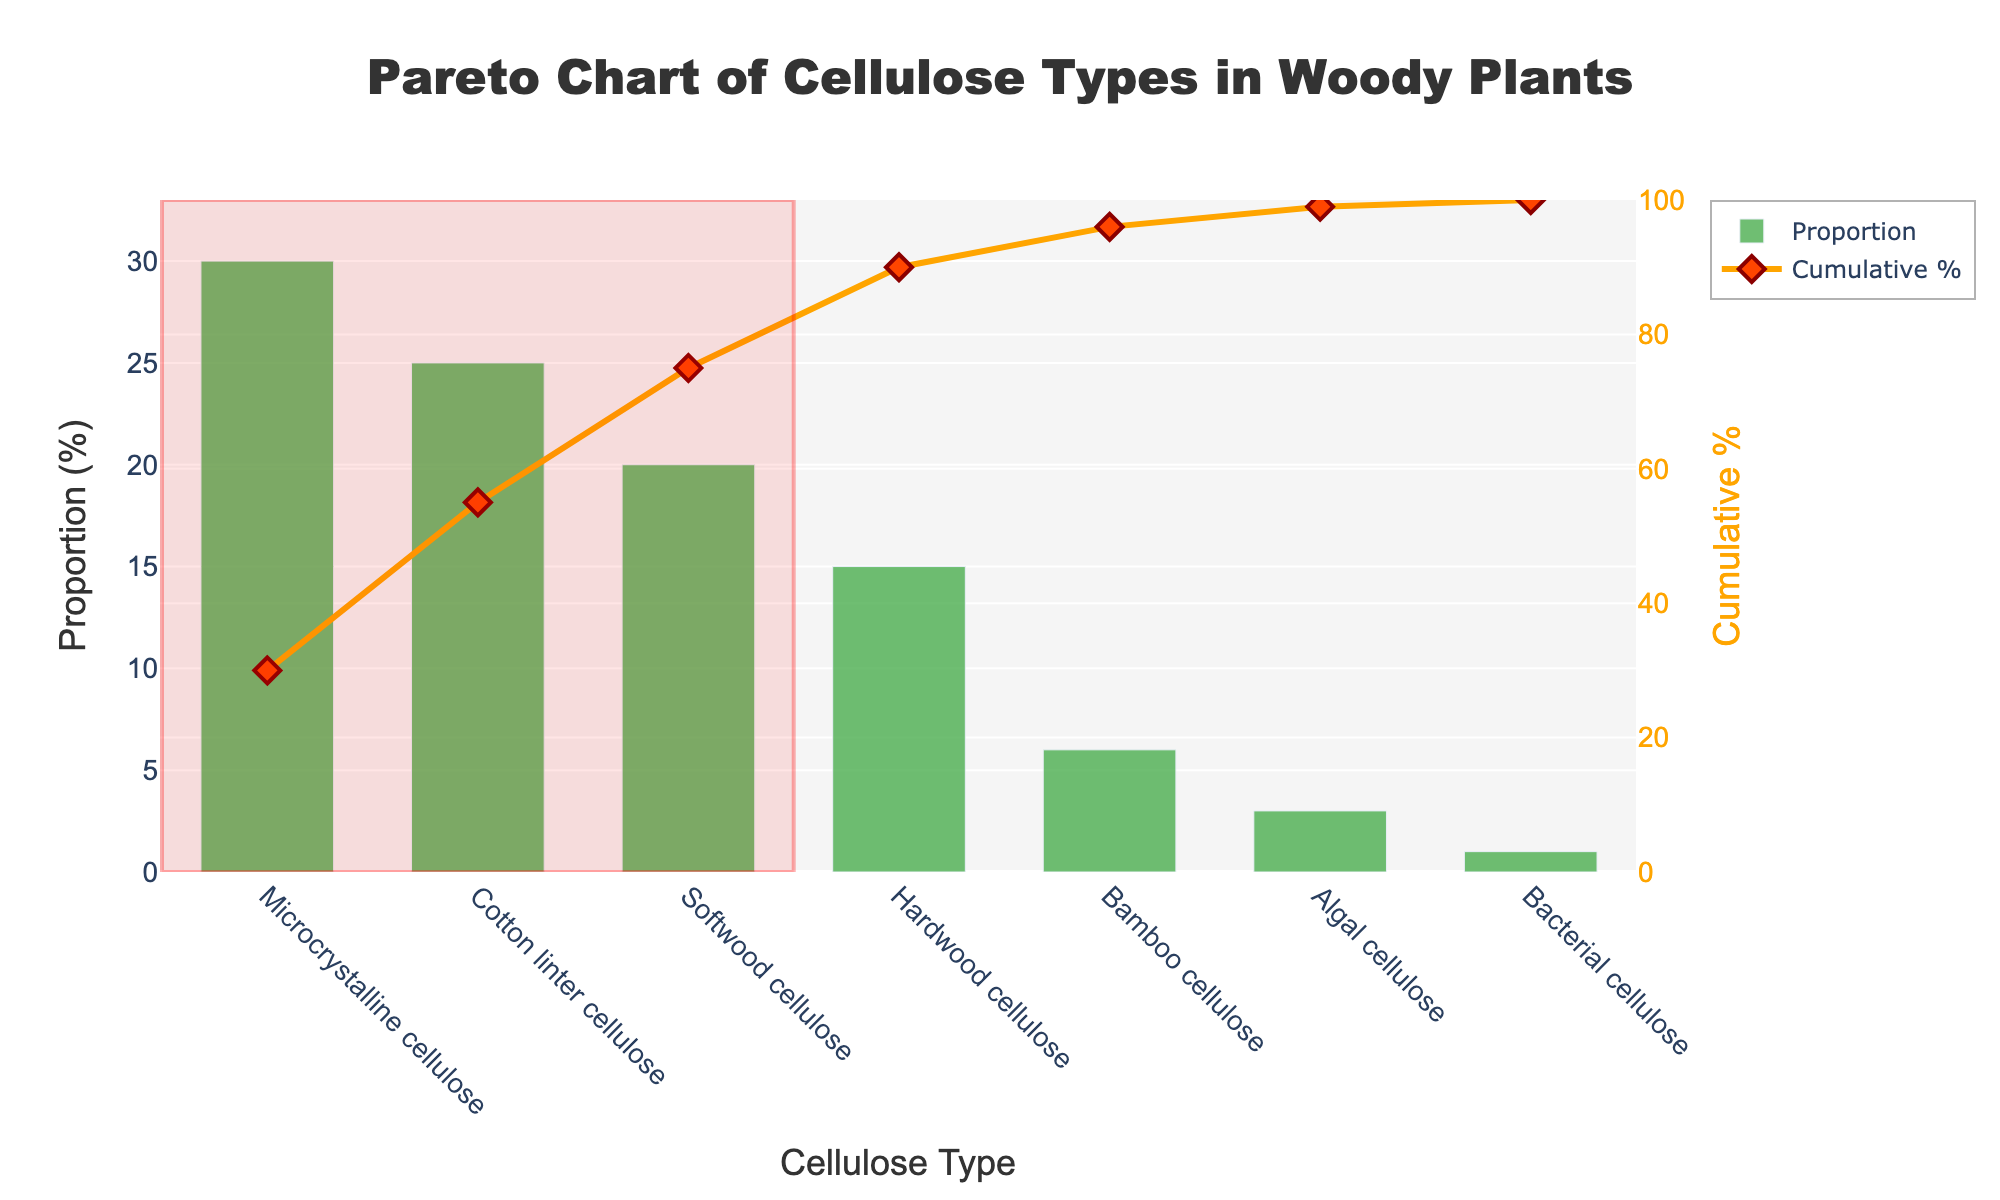What's the title of the figure? The title is prominently displayed at the top of the figure.
Answer: Pareto Chart of Cellulose Types in Woody Plants What do the x-axis and the left y-axis represent? The x-axis represents different types of cellulose, and the left y-axis represents the proportion (%) of each cellulose type.
Answer: Cellulose Type and Proportion (%) Which cellulose type has the highest proportion? The cellulose type with the highest bar indicates the highest proportion.
Answer: Microcrystalline cellulose What is the cumulative percentage shown when 'Softwood cellulose' is reached? The cumulative percentage line intersects 'Softwood cellulose' on the plot.
Answer: 75% How much higher is the Crystallinity Index of 'Microcrystalline cellulose' compared to 'Bacterial cellulose'? The Crystallinity Index for both types is shown; subtract the index of 'Bacterial cellulose' from 'Microcrystalline cellulose'.
Answer: 40 Which cellulose types make up approximately 80% of the total proportion? The highlighted region in the figure indicates the cellulose types contributing to about 80% of the total proportion.
Answer: Microcrystalline cellulose, Cotton linter cellulose, Softwood cellulose, Hardwood cellulose What is the color and shape of the markers used in the cumulative percentage line? The markers' color and shape are identified by observing the line chart overlay.
Answer: Diamond shape, orange color What is the cumulative percentage reached after 'Hardwood cellulose'? Follow the cumulative percentage line to the point right after 'Hardwood cellulose'.
Answer: 90% Which cellulose type has the lowest proportion? The cellulose type with the shortest bar indicates the lowest proportion.
Answer: Bacterial cellulose 